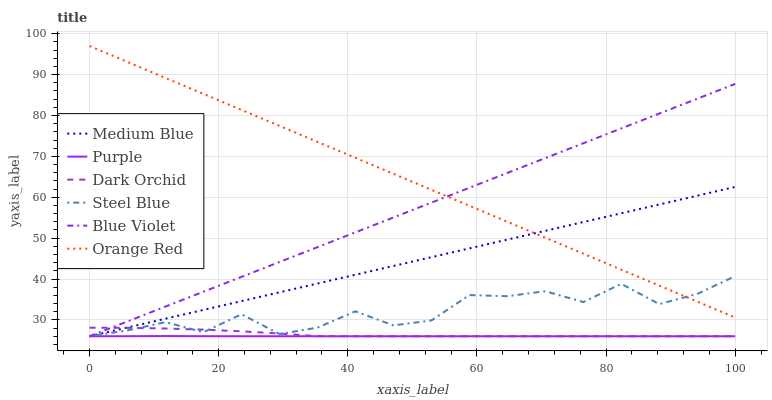Does Purple have the minimum area under the curve?
Answer yes or no. Yes. Does Orange Red have the maximum area under the curve?
Answer yes or no. Yes. Does Medium Blue have the minimum area under the curve?
Answer yes or no. No. Does Medium Blue have the maximum area under the curve?
Answer yes or no. No. Is Medium Blue the smoothest?
Answer yes or no. Yes. Is Steel Blue the roughest?
Answer yes or no. Yes. Is Steel Blue the smoothest?
Answer yes or no. No. Is Medium Blue the roughest?
Answer yes or no. No. Does Purple have the lowest value?
Answer yes or no. Yes. Does Orange Red have the lowest value?
Answer yes or no. No. Does Orange Red have the highest value?
Answer yes or no. Yes. Does Medium Blue have the highest value?
Answer yes or no. No. Is Dark Orchid less than Orange Red?
Answer yes or no. Yes. Is Orange Red greater than Purple?
Answer yes or no. Yes. Does Medium Blue intersect Blue Violet?
Answer yes or no. Yes. Is Medium Blue less than Blue Violet?
Answer yes or no. No. Is Medium Blue greater than Blue Violet?
Answer yes or no. No. Does Dark Orchid intersect Orange Red?
Answer yes or no. No. 